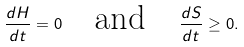<formula> <loc_0><loc_0><loc_500><loc_500>\frac { d H } { d t } = 0 \quad \text {and} \quad \frac { d S } { d t } \geq 0 .</formula> 